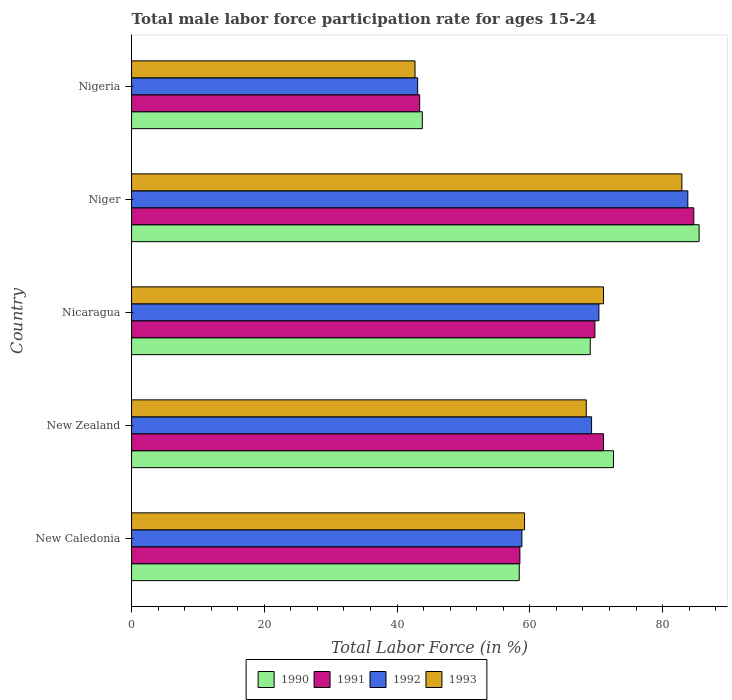How many groups of bars are there?
Ensure brevity in your answer.  5. Are the number of bars per tick equal to the number of legend labels?
Provide a succinct answer. Yes. Are the number of bars on each tick of the Y-axis equal?
Keep it short and to the point. Yes. What is the label of the 1st group of bars from the top?
Give a very brief answer. Nigeria. What is the male labor force participation rate in 1992 in Niger?
Your answer should be very brief. 83.8. Across all countries, what is the maximum male labor force participation rate in 1993?
Keep it short and to the point. 82.9. Across all countries, what is the minimum male labor force participation rate in 1993?
Offer a terse response. 42.7. In which country was the male labor force participation rate in 1992 maximum?
Provide a succinct answer. Niger. In which country was the male labor force participation rate in 1990 minimum?
Provide a succinct answer. Nigeria. What is the total male labor force participation rate in 1992 in the graph?
Give a very brief answer. 325.4. What is the difference between the male labor force participation rate in 1991 in Niger and that in Nigeria?
Your response must be concise. 41.3. What is the difference between the male labor force participation rate in 1990 in Niger and the male labor force participation rate in 1993 in New Zealand?
Your answer should be very brief. 17. What is the average male labor force participation rate in 1990 per country?
Your response must be concise. 65.88. What is the difference between the male labor force participation rate in 1991 and male labor force participation rate in 1990 in Nigeria?
Give a very brief answer. -0.4. What is the ratio of the male labor force participation rate in 1992 in New Zealand to that in Nicaragua?
Provide a short and direct response. 0.98. Is the difference between the male labor force participation rate in 1991 in Nicaragua and Nigeria greater than the difference between the male labor force participation rate in 1990 in Nicaragua and Nigeria?
Your answer should be very brief. Yes. What is the difference between the highest and the second highest male labor force participation rate in 1992?
Ensure brevity in your answer.  13.4. What is the difference between the highest and the lowest male labor force participation rate in 1992?
Provide a short and direct response. 40.7. Is it the case that in every country, the sum of the male labor force participation rate in 1993 and male labor force participation rate in 1992 is greater than the male labor force participation rate in 1990?
Your response must be concise. Yes. How many bars are there?
Offer a very short reply. 20. Are all the bars in the graph horizontal?
Provide a short and direct response. Yes. How many countries are there in the graph?
Provide a short and direct response. 5. Does the graph contain any zero values?
Your answer should be very brief. No. Where does the legend appear in the graph?
Keep it short and to the point. Bottom center. What is the title of the graph?
Provide a succinct answer. Total male labor force participation rate for ages 15-24. What is the label or title of the X-axis?
Your answer should be compact. Total Labor Force (in %). What is the label or title of the Y-axis?
Offer a very short reply. Country. What is the Total Labor Force (in %) in 1990 in New Caledonia?
Provide a short and direct response. 58.4. What is the Total Labor Force (in %) of 1991 in New Caledonia?
Give a very brief answer. 58.5. What is the Total Labor Force (in %) of 1992 in New Caledonia?
Provide a short and direct response. 58.8. What is the Total Labor Force (in %) in 1993 in New Caledonia?
Ensure brevity in your answer.  59.2. What is the Total Labor Force (in %) in 1990 in New Zealand?
Give a very brief answer. 72.6. What is the Total Labor Force (in %) in 1991 in New Zealand?
Your answer should be compact. 71.1. What is the Total Labor Force (in %) of 1992 in New Zealand?
Your answer should be very brief. 69.3. What is the Total Labor Force (in %) in 1993 in New Zealand?
Your response must be concise. 68.5. What is the Total Labor Force (in %) in 1990 in Nicaragua?
Provide a short and direct response. 69.1. What is the Total Labor Force (in %) of 1991 in Nicaragua?
Keep it short and to the point. 69.8. What is the Total Labor Force (in %) in 1992 in Nicaragua?
Your answer should be compact. 70.4. What is the Total Labor Force (in %) of 1993 in Nicaragua?
Give a very brief answer. 71.1. What is the Total Labor Force (in %) in 1990 in Niger?
Provide a succinct answer. 85.5. What is the Total Labor Force (in %) in 1991 in Niger?
Give a very brief answer. 84.7. What is the Total Labor Force (in %) in 1992 in Niger?
Make the answer very short. 83.8. What is the Total Labor Force (in %) of 1993 in Niger?
Provide a short and direct response. 82.9. What is the Total Labor Force (in %) in 1990 in Nigeria?
Offer a terse response. 43.8. What is the Total Labor Force (in %) in 1991 in Nigeria?
Your answer should be compact. 43.4. What is the Total Labor Force (in %) of 1992 in Nigeria?
Your answer should be compact. 43.1. What is the Total Labor Force (in %) in 1993 in Nigeria?
Make the answer very short. 42.7. Across all countries, what is the maximum Total Labor Force (in %) in 1990?
Offer a very short reply. 85.5. Across all countries, what is the maximum Total Labor Force (in %) in 1991?
Offer a very short reply. 84.7. Across all countries, what is the maximum Total Labor Force (in %) in 1992?
Make the answer very short. 83.8. Across all countries, what is the maximum Total Labor Force (in %) of 1993?
Ensure brevity in your answer.  82.9. Across all countries, what is the minimum Total Labor Force (in %) in 1990?
Offer a terse response. 43.8. Across all countries, what is the minimum Total Labor Force (in %) in 1991?
Offer a very short reply. 43.4. Across all countries, what is the minimum Total Labor Force (in %) of 1992?
Provide a succinct answer. 43.1. Across all countries, what is the minimum Total Labor Force (in %) in 1993?
Provide a succinct answer. 42.7. What is the total Total Labor Force (in %) in 1990 in the graph?
Give a very brief answer. 329.4. What is the total Total Labor Force (in %) of 1991 in the graph?
Offer a very short reply. 327.5. What is the total Total Labor Force (in %) of 1992 in the graph?
Offer a very short reply. 325.4. What is the total Total Labor Force (in %) of 1993 in the graph?
Provide a succinct answer. 324.4. What is the difference between the Total Labor Force (in %) in 1990 in New Caledonia and that in New Zealand?
Offer a very short reply. -14.2. What is the difference between the Total Labor Force (in %) in 1993 in New Caledonia and that in New Zealand?
Ensure brevity in your answer.  -9.3. What is the difference between the Total Labor Force (in %) in 1992 in New Caledonia and that in Nicaragua?
Your answer should be very brief. -11.6. What is the difference between the Total Labor Force (in %) in 1993 in New Caledonia and that in Nicaragua?
Provide a short and direct response. -11.9. What is the difference between the Total Labor Force (in %) in 1990 in New Caledonia and that in Niger?
Offer a very short reply. -27.1. What is the difference between the Total Labor Force (in %) in 1991 in New Caledonia and that in Niger?
Offer a terse response. -26.2. What is the difference between the Total Labor Force (in %) in 1993 in New Caledonia and that in Niger?
Your answer should be compact. -23.7. What is the difference between the Total Labor Force (in %) of 1991 in New Caledonia and that in Nigeria?
Your answer should be very brief. 15.1. What is the difference between the Total Labor Force (in %) of 1992 in New Caledonia and that in Nigeria?
Make the answer very short. 15.7. What is the difference between the Total Labor Force (in %) in 1992 in New Zealand and that in Nicaragua?
Offer a terse response. -1.1. What is the difference between the Total Labor Force (in %) in 1993 in New Zealand and that in Nicaragua?
Make the answer very short. -2.6. What is the difference between the Total Labor Force (in %) of 1990 in New Zealand and that in Niger?
Ensure brevity in your answer.  -12.9. What is the difference between the Total Labor Force (in %) of 1991 in New Zealand and that in Niger?
Your answer should be compact. -13.6. What is the difference between the Total Labor Force (in %) in 1993 in New Zealand and that in Niger?
Offer a terse response. -14.4. What is the difference between the Total Labor Force (in %) of 1990 in New Zealand and that in Nigeria?
Offer a terse response. 28.8. What is the difference between the Total Labor Force (in %) in 1991 in New Zealand and that in Nigeria?
Keep it short and to the point. 27.7. What is the difference between the Total Labor Force (in %) of 1992 in New Zealand and that in Nigeria?
Offer a very short reply. 26.2. What is the difference between the Total Labor Force (in %) of 1993 in New Zealand and that in Nigeria?
Keep it short and to the point. 25.8. What is the difference between the Total Labor Force (in %) in 1990 in Nicaragua and that in Niger?
Ensure brevity in your answer.  -16.4. What is the difference between the Total Labor Force (in %) in 1991 in Nicaragua and that in Niger?
Offer a very short reply. -14.9. What is the difference between the Total Labor Force (in %) of 1990 in Nicaragua and that in Nigeria?
Offer a very short reply. 25.3. What is the difference between the Total Labor Force (in %) of 1991 in Nicaragua and that in Nigeria?
Make the answer very short. 26.4. What is the difference between the Total Labor Force (in %) in 1992 in Nicaragua and that in Nigeria?
Provide a short and direct response. 27.3. What is the difference between the Total Labor Force (in %) of 1993 in Nicaragua and that in Nigeria?
Keep it short and to the point. 28.4. What is the difference between the Total Labor Force (in %) of 1990 in Niger and that in Nigeria?
Offer a terse response. 41.7. What is the difference between the Total Labor Force (in %) in 1991 in Niger and that in Nigeria?
Offer a terse response. 41.3. What is the difference between the Total Labor Force (in %) of 1992 in Niger and that in Nigeria?
Your answer should be compact. 40.7. What is the difference between the Total Labor Force (in %) in 1993 in Niger and that in Nigeria?
Your answer should be very brief. 40.2. What is the difference between the Total Labor Force (in %) of 1990 in New Caledonia and the Total Labor Force (in %) of 1991 in New Zealand?
Your answer should be compact. -12.7. What is the difference between the Total Labor Force (in %) in 1990 in New Caledonia and the Total Labor Force (in %) in 1993 in New Zealand?
Keep it short and to the point. -10.1. What is the difference between the Total Labor Force (in %) in 1990 in New Caledonia and the Total Labor Force (in %) in 1991 in Nicaragua?
Offer a terse response. -11.4. What is the difference between the Total Labor Force (in %) of 1991 in New Caledonia and the Total Labor Force (in %) of 1993 in Nicaragua?
Offer a very short reply. -12.6. What is the difference between the Total Labor Force (in %) in 1990 in New Caledonia and the Total Labor Force (in %) in 1991 in Niger?
Make the answer very short. -26.3. What is the difference between the Total Labor Force (in %) of 1990 in New Caledonia and the Total Labor Force (in %) of 1992 in Niger?
Your answer should be very brief. -25.4. What is the difference between the Total Labor Force (in %) in 1990 in New Caledonia and the Total Labor Force (in %) in 1993 in Niger?
Offer a very short reply. -24.5. What is the difference between the Total Labor Force (in %) in 1991 in New Caledonia and the Total Labor Force (in %) in 1992 in Niger?
Your answer should be compact. -25.3. What is the difference between the Total Labor Force (in %) of 1991 in New Caledonia and the Total Labor Force (in %) of 1993 in Niger?
Ensure brevity in your answer.  -24.4. What is the difference between the Total Labor Force (in %) of 1992 in New Caledonia and the Total Labor Force (in %) of 1993 in Niger?
Make the answer very short. -24.1. What is the difference between the Total Labor Force (in %) of 1990 in New Caledonia and the Total Labor Force (in %) of 1992 in Nigeria?
Keep it short and to the point. 15.3. What is the difference between the Total Labor Force (in %) of 1990 in New Caledonia and the Total Labor Force (in %) of 1993 in Nigeria?
Offer a terse response. 15.7. What is the difference between the Total Labor Force (in %) in 1991 in New Caledonia and the Total Labor Force (in %) in 1992 in Nigeria?
Offer a terse response. 15.4. What is the difference between the Total Labor Force (in %) in 1991 in New Zealand and the Total Labor Force (in %) in 1992 in Nicaragua?
Offer a terse response. 0.7. What is the difference between the Total Labor Force (in %) in 1991 in New Zealand and the Total Labor Force (in %) in 1993 in Nicaragua?
Provide a succinct answer. 0. What is the difference between the Total Labor Force (in %) of 1990 in New Zealand and the Total Labor Force (in %) of 1991 in Niger?
Ensure brevity in your answer.  -12.1. What is the difference between the Total Labor Force (in %) of 1991 in New Zealand and the Total Labor Force (in %) of 1992 in Niger?
Give a very brief answer. -12.7. What is the difference between the Total Labor Force (in %) of 1992 in New Zealand and the Total Labor Force (in %) of 1993 in Niger?
Your response must be concise. -13.6. What is the difference between the Total Labor Force (in %) in 1990 in New Zealand and the Total Labor Force (in %) in 1991 in Nigeria?
Offer a terse response. 29.2. What is the difference between the Total Labor Force (in %) in 1990 in New Zealand and the Total Labor Force (in %) in 1992 in Nigeria?
Keep it short and to the point. 29.5. What is the difference between the Total Labor Force (in %) of 1990 in New Zealand and the Total Labor Force (in %) of 1993 in Nigeria?
Ensure brevity in your answer.  29.9. What is the difference between the Total Labor Force (in %) in 1991 in New Zealand and the Total Labor Force (in %) in 1993 in Nigeria?
Offer a very short reply. 28.4. What is the difference between the Total Labor Force (in %) of 1992 in New Zealand and the Total Labor Force (in %) of 1993 in Nigeria?
Provide a succinct answer. 26.6. What is the difference between the Total Labor Force (in %) of 1990 in Nicaragua and the Total Labor Force (in %) of 1991 in Niger?
Make the answer very short. -15.6. What is the difference between the Total Labor Force (in %) in 1990 in Nicaragua and the Total Labor Force (in %) in 1992 in Niger?
Provide a short and direct response. -14.7. What is the difference between the Total Labor Force (in %) in 1991 in Nicaragua and the Total Labor Force (in %) in 1993 in Niger?
Your answer should be very brief. -13.1. What is the difference between the Total Labor Force (in %) in 1990 in Nicaragua and the Total Labor Force (in %) in 1991 in Nigeria?
Ensure brevity in your answer.  25.7. What is the difference between the Total Labor Force (in %) of 1990 in Nicaragua and the Total Labor Force (in %) of 1993 in Nigeria?
Your response must be concise. 26.4. What is the difference between the Total Labor Force (in %) in 1991 in Nicaragua and the Total Labor Force (in %) in 1992 in Nigeria?
Make the answer very short. 26.7. What is the difference between the Total Labor Force (in %) in 1991 in Nicaragua and the Total Labor Force (in %) in 1993 in Nigeria?
Keep it short and to the point. 27.1. What is the difference between the Total Labor Force (in %) of 1992 in Nicaragua and the Total Labor Force (in %) of 1993 in Nigeria?
Give a very brief answer. 27.7. What is the difference between the Total Labor Force (in %) of 1990 in Niger and the Total Labor Force (in %) of 1991 in Nigeria?
Your answer should be very brief. 42.1. What is the difference between the Total Labor Force (in %) of 1990 in Niger and the Total Labor Force (in %) of 1992 in Nigeria?
Give a very brief answer. 42.4. What is the difference between the Total Labor Force (in %) in 1990 in Niger and the Total Labor Force (in %) in 1993 in Nigeria?
Your answer should be compact. 42.8. What is the difference between the Total Labor Force (in %) of 1991 in Niger and the Total Labor Force (in %) of 1992 in Nigeria?
Make the answer very short. 41.6. What is the difference between the Total Labor Force (in %) of 1992 in Niger and the Total Labor Force (in %) of 1993 in Nigeria?
Keep it short and to the point. 41.1. What is the average Total Labor Force (in %) of 1990 per country?
Provide a short and direct response. 65.88. What is the average Total Labor Force (in %) of 1991 per country?
Your answer should be compact. 65.5. What is the average Total Labor Force (in %) of 1992 per country?
Provide a succinct answer. 65.08. What is the average Total Labor Force (in %) in 1993 per country?
Your answer should be compact. 64.88. What is the difference between the Total Labor Force (in %) in 1990 and Total Labor Force (in %) in 1992 in New Caledonia?
Offer a terse response. -0.4. What is the difference between the Total Labor Force (in %) in 1990 and Total Labor Force (in %) in 1993 in New Caledonia?
Your answer should be very brief. -0.8. What is the difference between the Total Labor Force (in %) in 1991 and Total Labor Force (in %) in 1992 in New Caledonia?
Your response must be concise. -0.3. What is the difference between the Total Labor Force (in %) in 1991 and Total Labor Force (in %) in 1993 in New Caledonia?
Your answer should be very brief. -0.7. What is the difference between the Total Labor Force (in %) in 1992 and Total Labor Force (in %) in 1993 in New Caledonia?
Offer a very short reply. -0.4. What is the difference between the Total Labor Force (in %) in 1990 and Total Labor Force (in %) in 1991 in New Zealand?
Make the answer very short. 1.5. What is the difference between the Total Labor Force (in %) in 1990 and Total Labor Force (in %) in 1992 in New Zealand?
Your response must be concise. 3.3. What is the difference between the Total Labor Force (in %) in 1990 and Total Labor Force (in %) in 1993 in New Zealand?
Keep it short and to the point. 4.1. What is the difference between the Total Labor Force (in %) of 1991 and Total Labor Force (in %) of 1992 in New Zealand?
Your answer should be compact. 1.8. What is the difference between the Total Labor Force (in %) of 1990 and Total Labor Force (in %) of 1991 in Nicaragua?
Offer a very short reply. -0.7. What is the difference between the Total Labor Force (in %) in 1990 and Total Labor Force (in %) in 1992 in Nicaragua?
Provide a succinct answer. -1.3. What is the difference between the Total Labor Force (in %) in 1990 and Total Labor Force (in %) in 1993 in Nicaragua?
Your answer should be very brief. -2. What is the difference between the Total Labor Force (in %) in 1991 and Total Labor Force (in %) in 1993 in Nicaragua?
Your answer should be very brief. -1.3. What is the difference between the Total Labor Force (in %) in 1991 and Total Labor Force (in %) in 1992 in Niger?
Keep it short and to the point. 0.9. What is the difference between the Total Labor Force (in %) in 1991 and Total Labor Force (in %) in 1993 in Niger?
Ensure brevity in your answer.  1.8. What is the difference between the Total Labor Force (in %) of 1990 and Total Labor Force (in %) of 1992 in Nigeria?
Provide a short and direct response. 0.7. What is the difference between the Total Labor Force (in %) in 1992 and Total Labor Force (in %) in 1993 in Nigeria?
Provide a short and direct response. 0.4. What is the ratio of the Total Labor Force (in %) of 1990 in New Caledonia to that in New Zealand?
Offer a very short reply. 0.8. What is the ratio of the Total Labor Force (in %) of 1991 in New Caledonia to that in New Zealand?
Ensure brevity in your answer.  0.82. What is the ratio of the Total Labor Force (in %) of 1992 in New Caledonia to that in New Zealand?
Offer a terse response. 0.85. What is the ratio of the Total Labor Force (in %) in 1993 in New Caledonia to that in New Zealand?
Keep it short and to the point. 0.86. What is the ratio of the Total Labor Force (in %) of 1990 in New Caledonia to that in Nicaragua?
Keep it short and to the point. 0.85. What is the ratio of the Total Labor Force (in %) in 1991 in New Caledonia to that in Nicaragua?
Your answer should be compact. 0.84. What is the ratio of the Total Labor Force (in %) of 1992 in New Caledonia to that in Nicaragua?
Your response must be concise. 0.84. What is the ratio of the Total Labor Force (in %) in 1993 in New Caledonia to that in Nicaragua?
Offer a very short reply. 0.83. What is the ratio of the Total Labor Force (in %) of 1990 in New Caledonia to that in Niger?
Offer a very short reply. 0.68. What is the ratio of the Total Labor Force (in %) of 1991 in New Caledonia to that in Niger?
Make the answer very short. 0.69. What is the ratio of the Total Labor Force (in %) of 1992 in New Caledonia to that in Niger?
Your answer should be very brief. 0.7. What is the ratio of the Total Labor Force (in %) in 1993 in New Caledonia to that in Niger?
Offer a terse response. 0.71. What is the ratio of the Total Labor Force (in %) of 1990 in New Caledonia to that in Nigeria?
Give a very brief answer. 1.33. What is the ratio of the Total Labor Force (in %) of 1991 in New Caledonia to that in Nigeria?
Give a very brief answer. 1.35. What is the ratio of the Total Labor Force (in %) in 1992 in New Caledonia to that in Nigeria?
Your answer should be very brief. 1.36. What is the ratio of the Total Labor Force (in %) of 1993 in New Caledonia to that in Nigeria?
Provide a short and direct response. 1.39. What is the ratio of the Total Labor Force (in %) in 1990 in New Zealand to that in Nicaragua?
Your answer should be very brief. 1.05. What is the ratio of the Total Labor Force (in %) in 1991 in New Zealand to that in Nicaragua?
Give a very brief answer. 1.02. What is the ratio of the Total Labor Force (in %) in 1992 in New Zealand to that in Nicaragua?
Offer a very short reply. 0.98. What is the ratio of the Total Labor Force (in %) of 1993 in New Zealand to that in Nicaragua?
Provide a succinct answer. 0.96. What is the ratio of the Total Labor Force (in %) of 1990 in New Zealand to that in Niger?
Provide a succinct answer. 0.85. What is the ratio of the Total Labor Force (in %) of 1991 in New Zealand to that in Niger?
Provide a succinct answer. 0.84. What is the ratio of the Total Labor Force (in %) of 1992 in New Zealand to that in Niger?
Your response must be concise. 0.83. What is the ratio of the Total Labor Force (in %) in 1993 in New Zealand to that in Niger?
Offer a terse response. 0.83. What is the ratio of the Total Labor Force (in %) of 1990 in New Zealand to that in Nigeria?
Ensure brevity in your answer.  1.66. What is the ratio of the Total Labor Force (in %) in 1991 in New Zealand to that in Nigeria?
Provide a short and direct response. 1.64. What is the ratio of the Total Labor Force (in %) of 1992 in New Zealand to that in Nigeria?
Keep it short and to the point. 1.61. What is the ratio of the Total Labor Force (in %) in 1993 in New Zealand to that in Nigeria?
Give a very brief answer. 1.6. What is the ratio of the Total Labor Force (in %) in 1990 in Nicaragua to that in Niger?
Your response must be concise. 0.81. What is the ratio of the Total Labor Force (in %) in 1991 in Nicaragua to that in Niger?
Provide a succinct answer. 0.82. What is the ratio of the Total Labor Force (in %) in 1992 in Nicaragua to that in Niger?
Give a very brief answer. 0.84. What is the ratio of the Total Labor Force (in %) in 1993 in Nicaragua to that in Niger?
Keep it short and to the point. 0.86. What is the ratio of the Total Labor Force (in %) in 1990 in Nicaragua to that in Nigeria?
Make the answer very short. 1.58. What is the ratio of the Total Labor Force (in %) in 1991 in Nicaragua to that in Nigeria?
Ensure brevity in your answer.  1.61. What is the ratio of the Total Labor Force (in %) in 1992 in Nicaragua to that in Nigeria?
Provide a succinct answer. 1.63. What is the ratio of the Total Labor Force (in %) in 1993 in Nicaragua to that in Nigeria?
Make the answer very short. 1.67. What is the ratio of the Total Labor Force (in %) of 1990 in Niger to that in Nigeria?
Give a very brief answer. 1.95. What is the ratio of the Total Labor Force (in %) in 1991 in Niger to that in Nigeria?
Offer a terse response. 1.95. What is the ratio of the Total Labor Force (in %) in 1992 in Niger to that in Nigeria?
Offer a terse response. 1.94. What is the ratio of the Total Labor Force (in %) of 1993 in Niger to that in Nigeria?
Give a very brief answer. 1.94. What is the difference between the highest and the second highest Total Labor Force (in %) in 1990?
Your answer should be compact. 12.9. What is the difference between the highest and the second highest Total Labor Force (in %) in 1993?
Your answer should be compact. 11.8. What is the difference between the highest and the lowest Total Labor Force (in %) in 1990?
Your response must be concise. 41.7. What is the difference between the highest and the lowest Total Labor Force (in %) of 1991?
Offer a terse response. 41.3. What is the difference between the highest and the lowest Total Labor Force (in %) of 1992?
Keep it short and to the point. 40.7. What is the difference between the highest and the lowest Total Labor Force (in %) of 1993?
Keep it short and to the point. 40.2. 